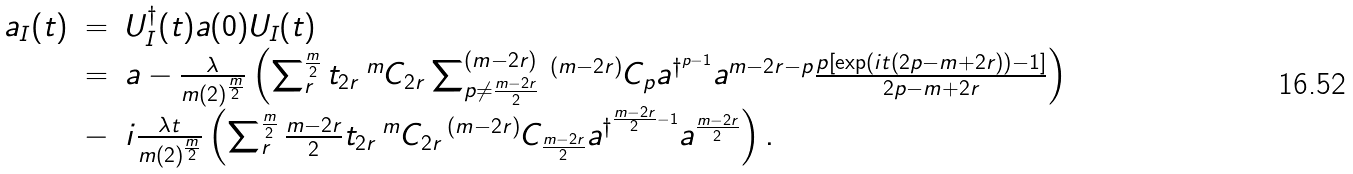Convert formula to latex. <formula><loc_0><loc_0><loc_500><loc_500>\begin{array} { l c l } a _ { I } ( t ) & = & U ^ { \dagger } _ { I } ( t ) a ( 0 ) U _ { I } ( t ) \\ & = & a - \frac { \lambda } { m ( 2 ) ^ { \frac { m } { 2 } } } \left ( \sum ^ { \frac { m } { 2 } } _ { r } t _ { 2 r } \, ^ { m } C _ { 2 r } \sum ^ { ( m - 2 r ) } _ { p \neq \frac { m - 2 r } { 2 } } \, ^ { ( m - 2 r ) } C _ { p } a ^ { \dagger ^ { p - 1 } } a ^ { m - 2 r - p } \frac { p \left [ \exp \left ( i t ( 2 p - m + 2 r ) \right ) - 1 \right ] } { 2 p - m + 2 r } \right ) \\ & - & i \frac { \lambda t } { m ( 2 ) ^ { \frac { m } { 2 } } } \left ( \sum ^ { \frac { m } { 2 } } _ { r } \frac { m - 2 r } { 2 } t _ { 2 r } \, ^ { m } C _ { 2 r } \, ^ { ( m - 2 r ) } C _ { \frac { m - 2 r } { 2 } } a ^ { \dagger ^ { \frac { m - 2 r } { 2 } - 1 } } a ^ { \frac { m - 2 r } { 2 } } \right ) . \end{array}</formula> 